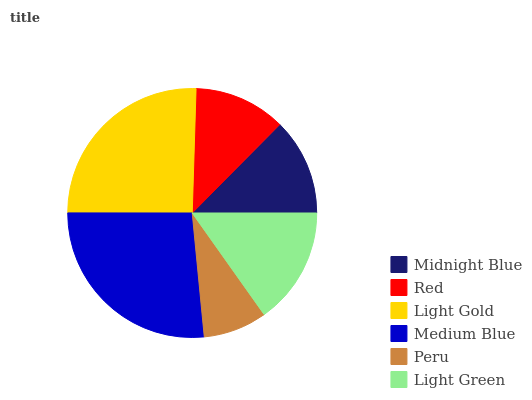Is Peru the minimum?
Answer yes or no. Yes. Is Medium Blue the maximum?
Answer yes or no. Yes. Is Red the minimum?
Answer yes or no. No. Is Red the maximum?
Answer yes or no. No. Is Midnight Blue greater than Red?
Answer yes or no. Yes. Is Red less than Midnight Blue?
Answer yes or no. Yes. Is Red greater than Midnight Blue?
Answer yes or no. No. Is Midnight Blue less than Red?
Answer yes or no. No. Is Light Green the high median?
Answer yes or no. Yes. Is Midnight Blue the low median?
Answer yes or no. Yes. Is Light Gold the high median?
Answer yes or no. No. Is Medium Blue the low median?
Answer yes or no. No. 